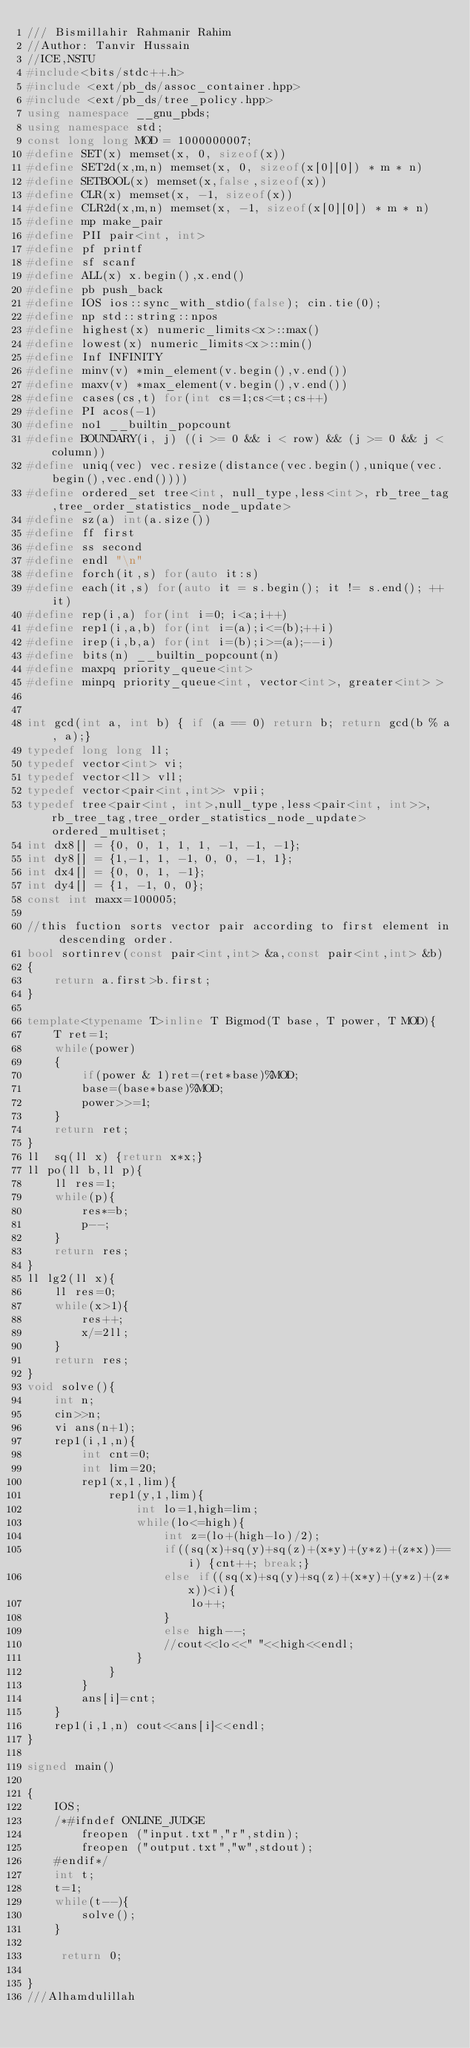Convert code to text. <code><loc_0><loc_0><loc_500><loc_500><_C++_>/// Bismillahir Rahmanir Rahim
//Author: Tanvir Hussain
//ICE,NSTU
#include<bits/stdc++.h>
#include <ext/pb_ds/assoc_container.hpp>
#include <ext/pb_ds/tree_policy.hpp>
using namespace __gnu_pbds;
using namespace std;
const long long MOD = 1000000007;
#define SET(x) memset(x, 0, sizeof(x))
#define SET2d(x,m,n) memset(x, 0, sizeof(x[0][0]) * m * n)
#define SETBOOL(x) memset(x,false,sizeof(x))
#define CLR(x) memset(x, -1, sizeof(x))
#define CLR2d(x,m,n) memset(x, -1, sizeof(x[0][0]) * m * n)
#define mp make_pair
#define PII pair<int, int>
#define pf printf
#define sf scanf
#define ALL(x) x.begin(),x.end()
#define pb push_back
#define IOS ios::sync_with_stdio(false); cin.tie(0);
#define np std::string::npos
#define highest(x) numeric_limits<x>::max()
#define lowest(x) numeric_limits<x>::min()
#define Inf INFINITY
#define minv(v) *min_element(v.begin(),v.end())
#define maxv(v) *max_element(v.begin(),v.end())
#define cases(cs,t) for(int cs=1;cs<=t;cs++)
#define PI acos(-1)
#define no1 __builtin_popcount
#define BOUNDARY(i, j) ((i >= 0 && i < row) && (j >= 0 && j < column))
#define uniq(vec) vec.resize(distance(vec.begin(),unique(vec.begin(),vec.end())))
#define ordered_set tree<int, null_type,less<int>, rb_tree_tag,tree_order_statistics_node_update>
#define sz(a) int(a.size())
#define ff first
#define ss second
#define endl "\n"
#define forch(it,s) for(auto it:s)
#define each(it,s) for(auto it = s.begin(); it != s.end(); ++it)
#define rep(i,a) for(int i=0; i<a;i++)
#define rep1(i,a,b) for(int i=(a);i<=(b);++i)
#define irep(i,b,a) for(int i=(b);i>=(a);--i)
#define bits(n) __builtin_popcount(n)
#define maxpq priority_queue<int>
#define minpq priority_queue<int, vector<int>, greater<int> >


int gcd(int a, int b) { if (a == 0) return b; return gcd(b % a, a);}
typedef long long ll;
typedef vector<int> vi;
typedef vector<ll> vll;
typedef vector<pair<int,int>> vpii;
typedef tree<pair<int, int>,null_type,less<pair<int, int>>,rb_tree_tag,tree_order_statistics_node_update> ordered_multiset;
int dx8[] = {0, 0, 1, 1, 1, -1, -1, -1};
int dy8[] = {1,-1, 1, -1, 0, 0, -1, 1};
int dx4[] = {0, 0, 1, -1};
int dy4[] = {1, -1, 0, 0};
const int maxx=100005;

//this fuction sorts vector pair according to first element in descending order.
bool sortinrev(const pair<int,int> &a,const pair<int,int> &b)
{
    return a.first>b.first;
}

template<typename T>inline T Bigmod(T base, T power, T MOD){
    T ret=1;
    while(power)
    {
        if(power & 1)ret=(ret*base)%MOD;
        base=(base*base)%MOD;
        power>>=1;
    }
    return ret;
}
ll  sq(ll x) {return x*x;}
ll po(ll b,ll p){
    ll res=1;
    while(p){
        res*=b;
        p--;
    }
    return res;
}
ll lg2(ll x){
    ll res=0;
    while(x>1){
        res++;
        x/=2ll;
    }
    return res;
}
void solve(){
    int n;
    cin>>n;
    vi ans(n+1);
    rep1(i,1,n){
        int cnt=0;
        int lim=20;
        rep1(x,1,lim){
            rep1(y,1,lim){
                int lo=1,high=lim;
                while(lo<=high){
                    int z=(lo+(high-lo)/2);
                    if((sq(x)+sq(y)+sq(z)+(x*y)+(y*z)+(z*x))==i) {cnt++; break;}
                    else if((sq(x)+sq(y)+sq(z)+(x*y)+(y*z)+(z*x))<i){
                        lo++;
                    }
                    else high--;
                    //cout<<lo<<" "<<high<<endl;
                }
            }
        }
        ans[i]=cnt;
    }
    rep1(i,1,n) cout<<ans[i]<<endl;
}

signed main()

{
    IOS;
    /*#ifndef ONLINE_JUDGE
        freopen ("input.txt","r",stdin);
        freopen ("output.txt","w",stdout);
    #endif*/
    int t;
    t=1;
    while(t--){
        solve();
    }

     return 0;

}
///Alhamdulillah


</code> 